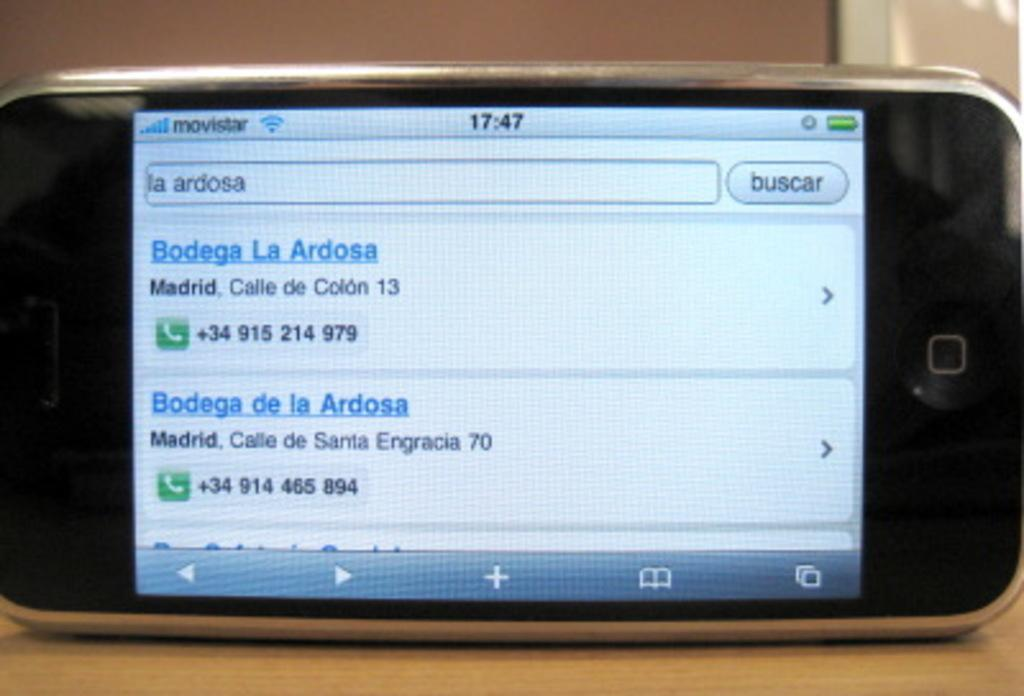<image>
Present a compact description of the photo's key features. A cell phone screen display shows addresses and phone numbers for Bodega La Ardosa 